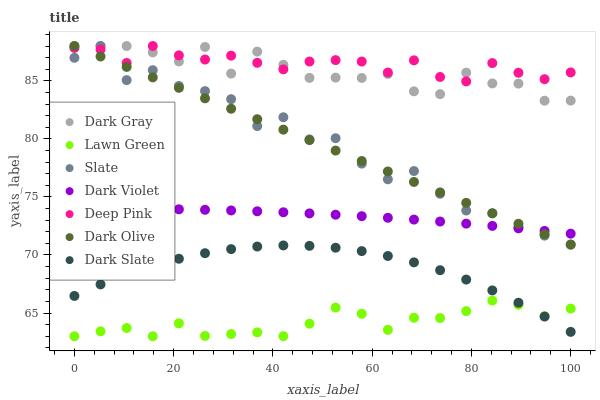Does Lawn Green have the minimum area under the curve?
Answer yes or no. Yes. Does Deep Pink have the maximum area under the curve?
Answer yes or no. Yes. Does Slate have the minimum area under the curve?
Answer yes or no. No. Does Slate have the maximum area under the curve?
Answer yes or no. No. Is Dark Olive the smoothest?
Answer yes or no. Yes. Is Slate the roughest?
Answer yes or no. Yes. Is Deep Pink the smoothest?
Answer yes or no. No. Is Deep Pink the roughest?
Answer yes or no. No. Does Lawn Green have the lowest value?
Answer yes or no. Yes. Does Slate have the lowest value?
Answer yes or no. No. Does Dark Gray have the highest value?
Answer yes or no. Yes. Does Dark Violet have the highest value?
Answer yes or no. No. Is Dark Slate less than Dark Violet?
Answer yes or no. Yes. Is Dark Violet greater than Lawn Green?
Answer yes or no. Yes. Does Dark Gray intersect Slate?
Answer yes or no. Yes. Is Dark Gray less than Slate?
Answer yes or no. No. Is Dark Gray greater than Slate?
Answer yes or no. No. Does Dark Slate intersect Dark Violet?
Answer yes or no. No. 